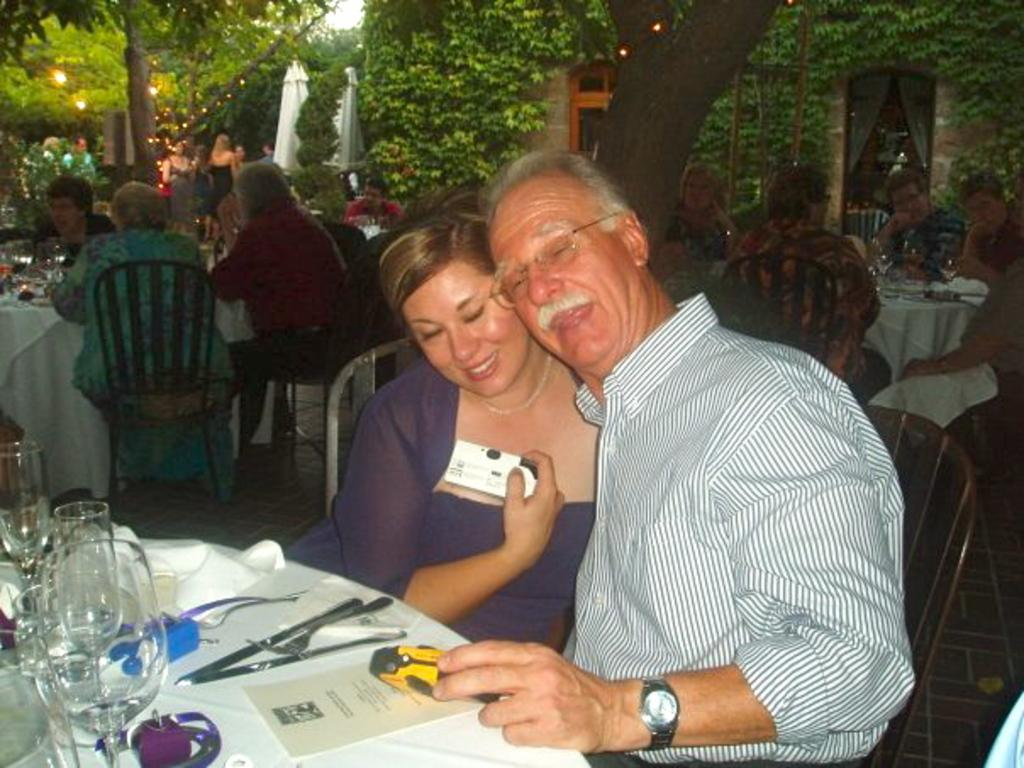What are the people in the image doing? The people in the image are sitting in a group. What are the people sitting on? The people are sitting on chairs. Can you describe any objects held by the people? One person is holding a toy. What items can be seen on the table? There are glasses, cloth, papers, a knife, and a toy on the table. What is visible in the background of the image? Trees, lights, people, and a house are visible in the background. What type of polish is being applied to the cherry on the table? There is no cherry or polish present in the image. Where is the basin located in the image? There is no basin present in the image. 